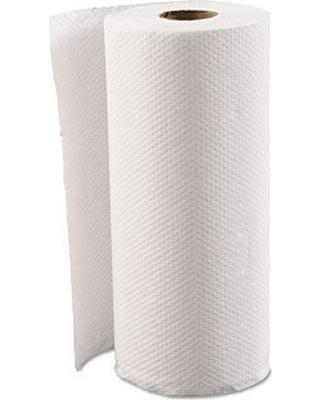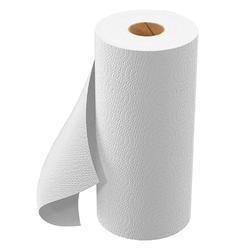The first image is the image on the left, the second image is the image on the right. Assess this claim about the two images: "A hand is reaching toward a white towel in a dispenser.". Correct or not? Answer yes or no. No. The first image is the image on the left, the second image is the image on the right. Examine the images to the left and right. Is the description "The image on the left shows a human hand holding a paper towel." accurate? Answer yes or no. No. 